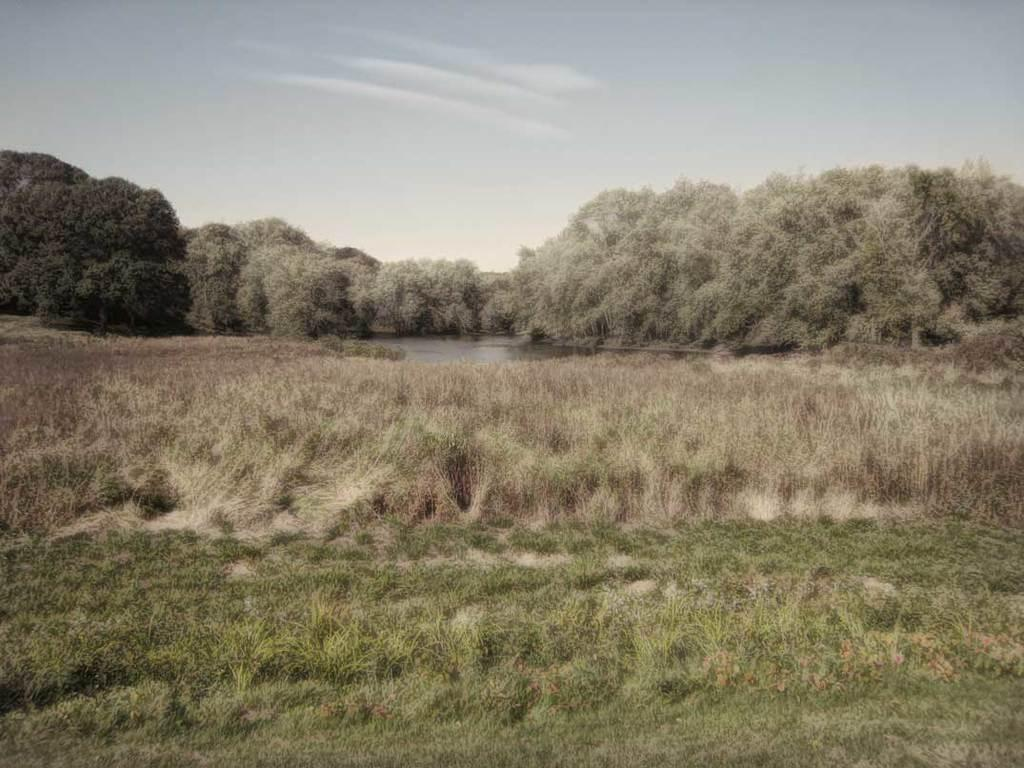What type of terrain is visible in the image? There is land full of grass in the image. What body of water is located behind the land? There is a lake behind the land. What kind of vegetation is present around the lake? Many trees are present around the lake. Can you describe the form of the squirrel sitting under the tree near the lake? There is no squirrel present in the image; it only features land, grass, a lake, and trees. What type of shade is provided by the trees around the lake? The question is not relevant to the image, as there is no mention of shade or any object that could provide shade. 